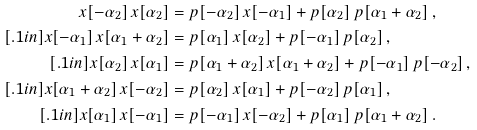Convert formula to latex. <formula><loc_0><loc_0><loc_500><loc_500>x [ - \alpha _ { 2 } ] \, x [ \alpha _ { 2 } ] & = p [ - \alpha _ { 2 } ] \, x [ - \alpha _ { 1 } ] + p [ \alpha _ { 2 } ] \, p [ \alpha _ { 1 } + \alpha _ { 2 } ] \, , \\ [ . 1 i n ] x [ - \alpha _ { 1 } ] \, x [ \alpha _ { 1 } + \alpha _ { 2 } ] & = p [ \alpha _ { 1 } ] \, x [ \alpha _ { 2 } ] + p [ - \alpha _ { 1 } ] \, p [ \alpha _ { 2 } ] \, , \\ [ . 1 i n ] x [ \alpha _ { 2 } ] \, x [ \alpha _ { 1 } ] & = p [ \alpha _ { 1 } + \alpha _ { 2 } ] \, x [ \alpha _ { 1 } + \alpha _ { 2 } ] + p [ - \alpha _ { 1 } ] \, p [ - \alpha _ { 2 } ] \, , \\ [ . 1 i n ] x [ \alpha _ { 1 } + \alpha _ { 2 } ] \, x [ - \alpha _ { 2 } ] & = p [ \alpha _ { 2 } ] \, x [ \alpha _ { 1 } ] + p [ - \alpha _ { 2 } ] \, p [ \alpha _ { 1 } ] \, , \\ [ . 1 i n ] x [ \alpha _ { 1 } ] \, x [ - \alpha _ { 1 } ] & = p [ - \alpha _ { 1 } ] \, x [ - \alpha _ { 2 } ] + p [ \alpha _ { 1 } ] \, p [ \alpha _ { 1 } + \alpha _ { 2 } ] \, .</formula> 